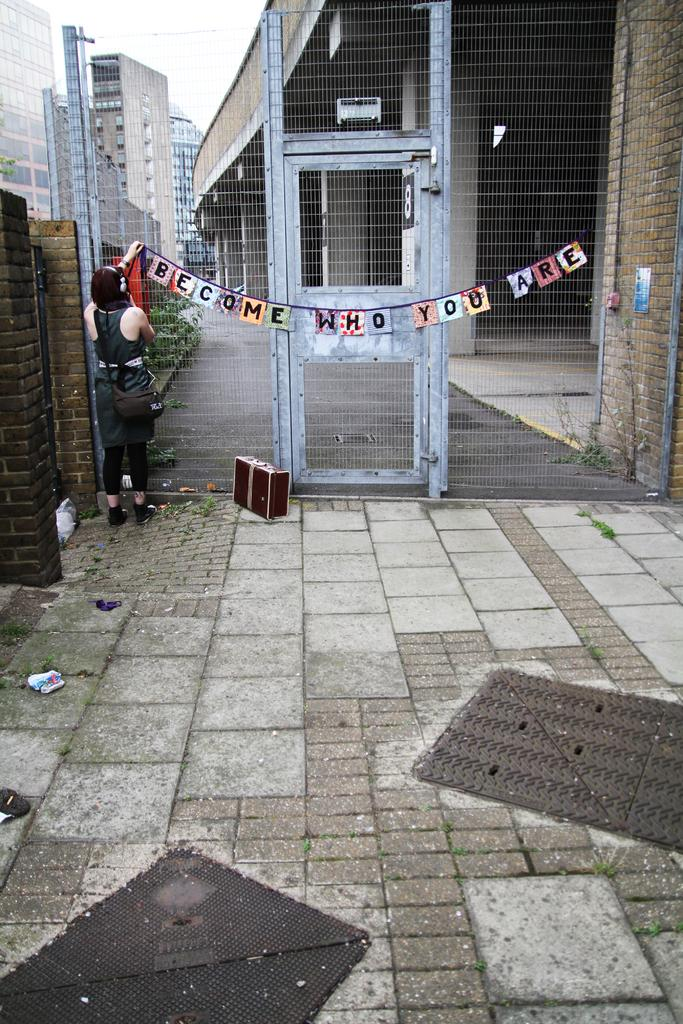<image>
Offer a succinct explanation of the picture presented. A women holds up an end of a banner sign that reads Become Who You Are. 